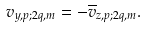<formula> <loc_0><loc_0><loc_500><loc_500>v _ { y , p ; 2 q , m } = - \overline { v } _ { z , p ; 2 q , m } .</formula> 